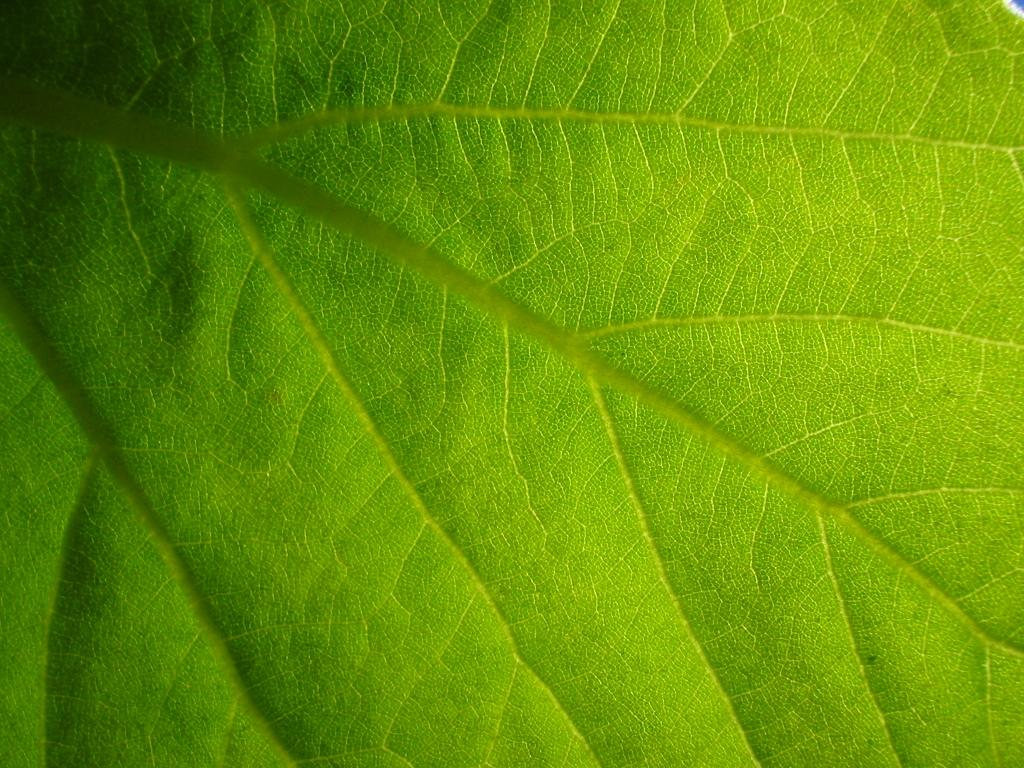What is present in the image? There is a leaf in the image. Can you describe the appearance of the leaf? The leaf is green in color. What time does the girl's aunt arrive in the image? There is no girl or aunt present in the image; it only features a leaf. 